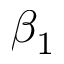Convert formula to latex. <formula><loc_0><loc_0><loc_500><loc_500>\beta _ { 1 }</formula> 